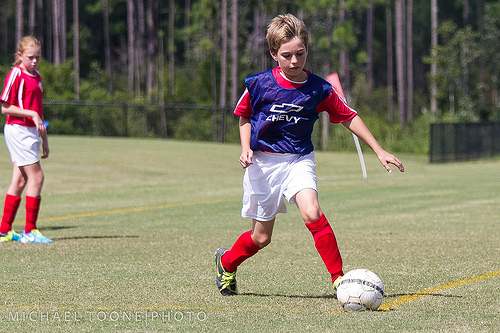<image>
Is the ball behind the boy? No. The ball is not behind the boy. From this viewpoint, the ball appears to be positioned elsewhere in the scene. Is there a ball in the boy? No. The ball is not contained within the boy. These objects have a different spatial relationship. 